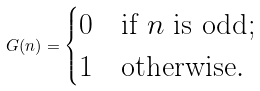Convert formula to latex. <formula><loc_0><loc_0><loc_500><loc_500>\ G ( n ) = \begin{cases} 0 & \text {if $n$ is odd} ; \\ 1 & \text {otherwise} . \end{cases}</formula> 